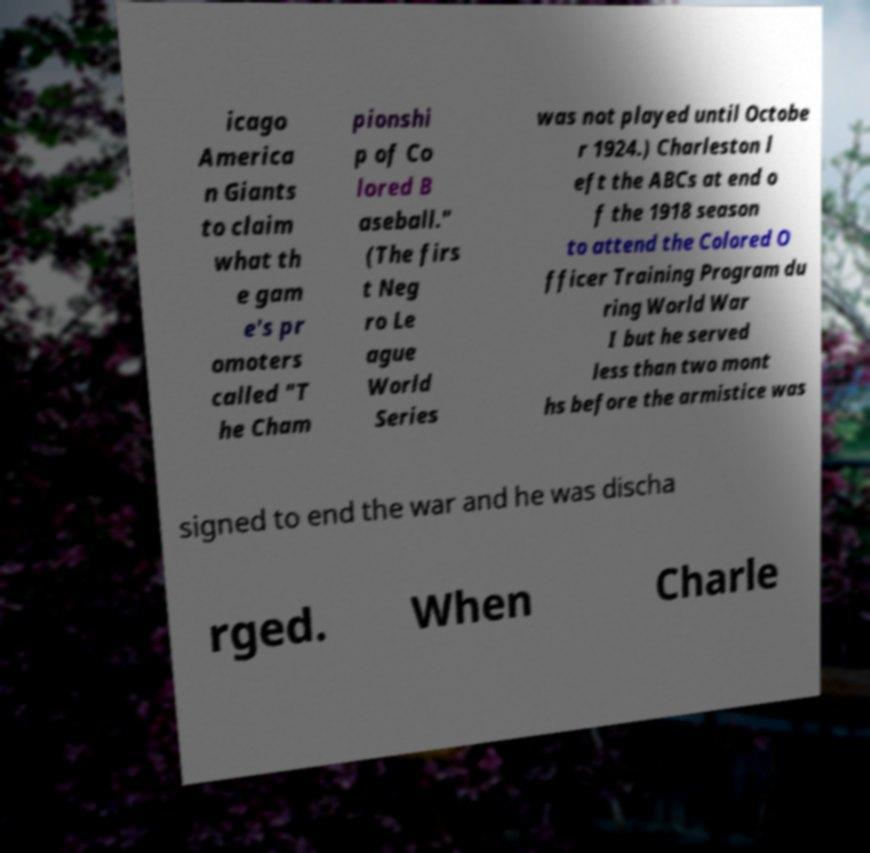Could you extract and type out the text from this image? icago America n Giants to claim what th e gam e's pr omoters called "T he Cham pionshi p of Co lored B aseball." (The firs t Neg ro Le ague World Series was not played until Octobe r 1924.) Charleston l eft the ABCs at end o f the 1918 season to attend the Colored O fficer Training Program du ring World War I but he served less than two mont hs before the armistice was signed to end the war and he was discha rged. When Charle 